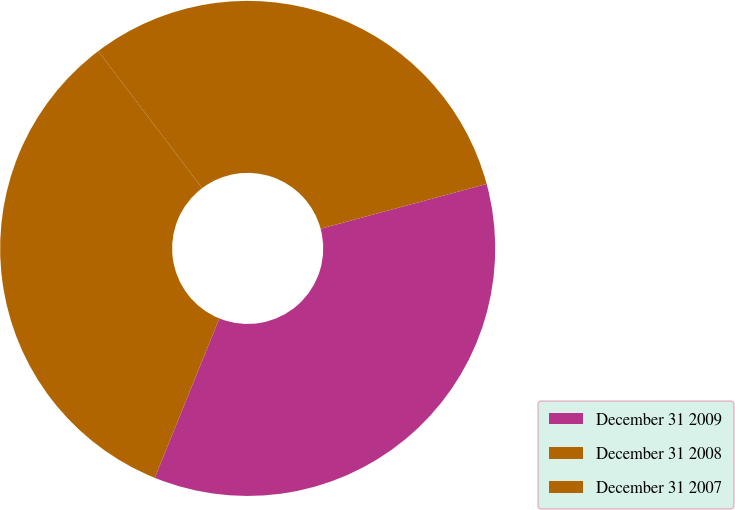<chart> <loc_0><loc_0><loc_500><loc_500><pie_chart><fcel>December 31 2009<fcel>December 31 2008<fcel>December 31 2007<nl><fcel>35.32%<fcel>33.57%<fcel>31.12%<nl></chart> 